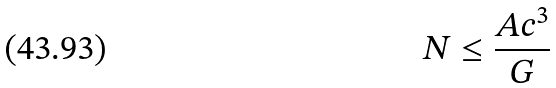<formula> <loc_0><loc_0><loc_500><loc_500>N \leq \frac { A c ^ { 3 } } { G }</formula> 